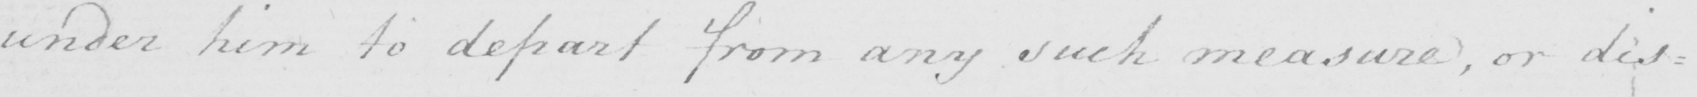What is written in this line of handwriting? under him to depart from any such measure  , or dis= 